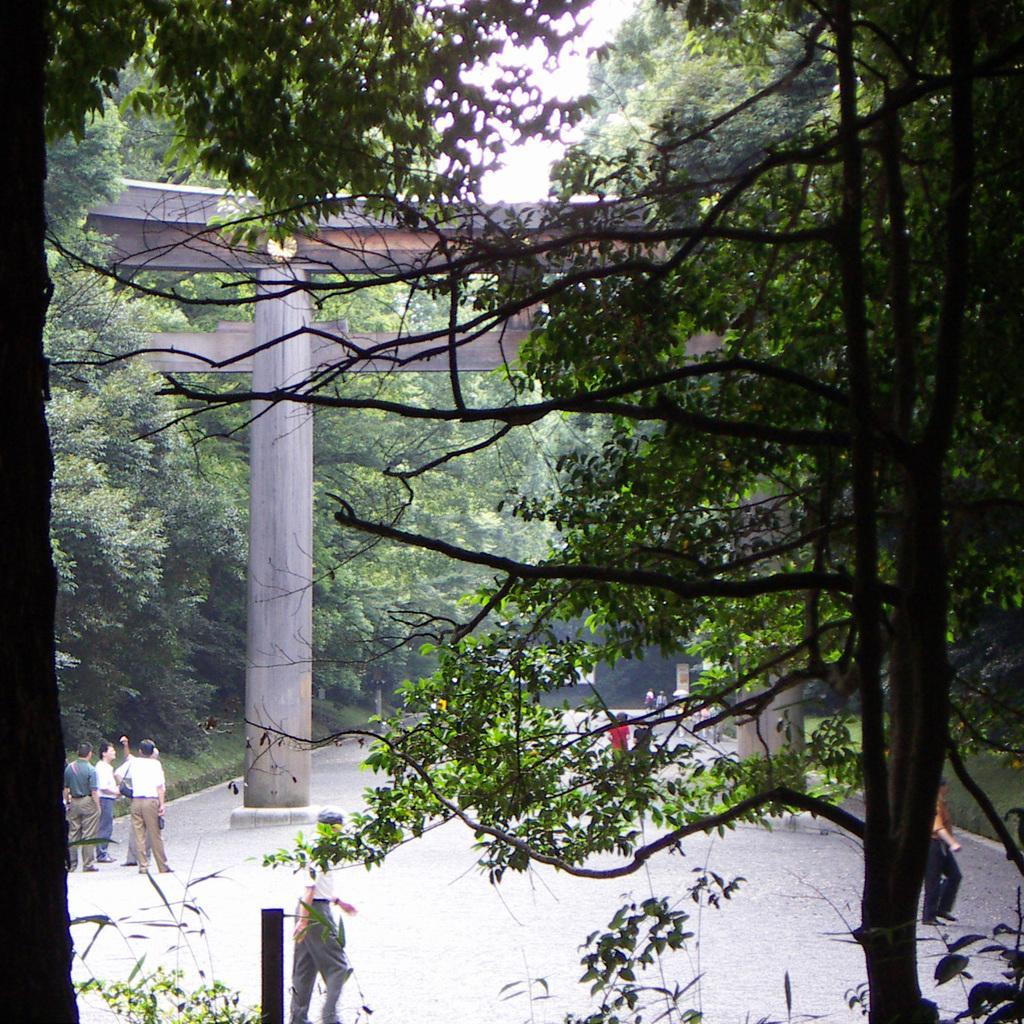Could you give a brief overview of what you see in this image? In this image I can see trees and people standing on the ground. Here I can see pillars and street light. In the background I can see the sky. 